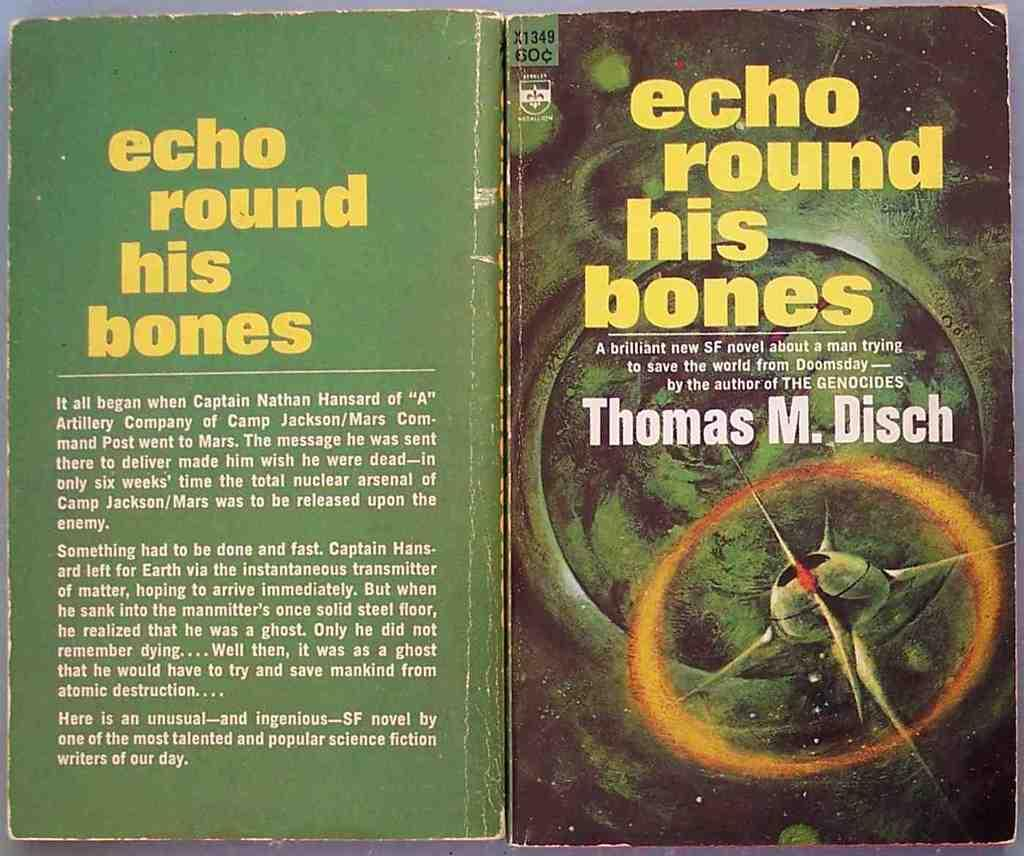<image>
Create a compact narrative representing the image presented. Echo Round his bones, a book, is open so that both covers are visible. 